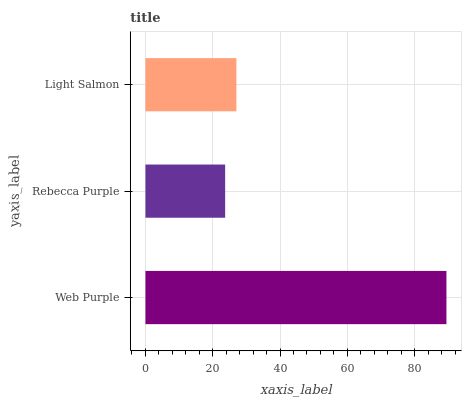Is Rebecca Purple the minimum?
Answer yes or no. Yes. Is Web Purple the maximum?
Answer yes or no. Yes. Is Light Salmon the minimum?
Answer yes or no. No. Is Light Salmon the maximum?
Answer yes or no. No. Is Light Salmon greater than Rebecca Purple?
Answer yes or no. Yes. Is Rebecca Purple less than Light Salmon?
Answer yes or no. Yes. Is Rebecca Purple greater than Light Salmon?
Answer yes or no. No. Is Light Salmon less than Rebecca Purple?
Answer yes or no. No. Is Light Salmon the high median?
Answer yes or no. Yes. Is Light Salmon the low median?
Answer yes or no. Yes. Is Web Purple the high median?
Answer yes or no. No. Is Rebecca Purple the low median?
Answer yes or no. No. 